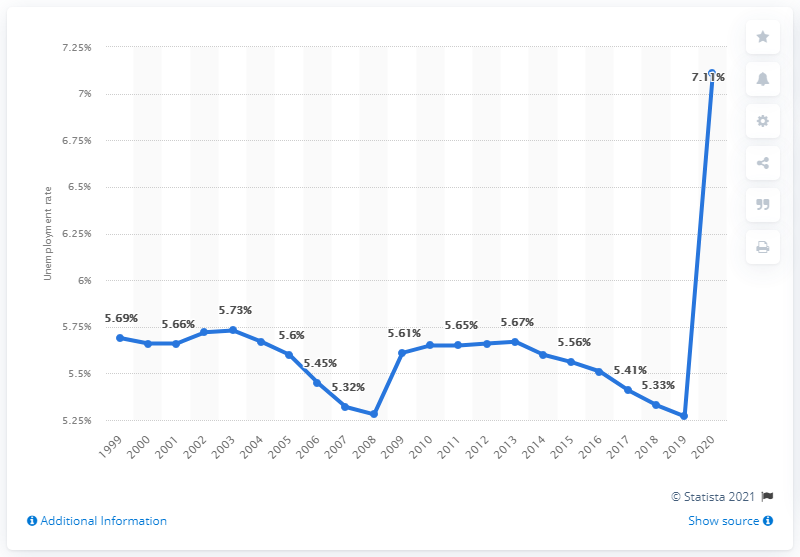List a handful of essential elements in this visual. According to data from 2020, the unemployment rate in India was 7.11%. In the year that the blue line graph crossed 7% marks, it was 2020. In 2020, the employment rate was at its highest. 